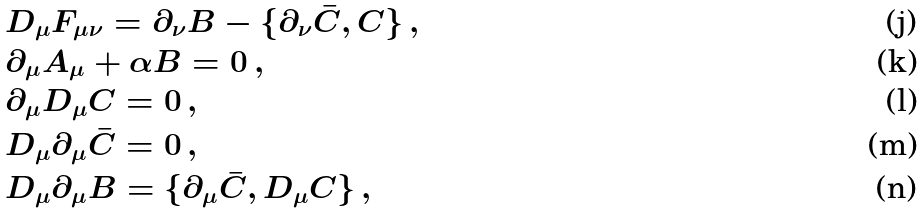<formula> <loc_0><loc_0><loc_500><loc_500>& D _ { \mu } F _ { \mu \nu } = \partial _ { \nu } B - \{ \partial _ { \nu } \bar { C } , C \} \, , \\ & \partial _ { \mu } A _ { \mu } + \alpha B = 0 \, , \\ & \partial _ { \mu } D _ { \mu } C = 0 \, , \\ & D _ { \mu } \partial _ { \mu } \bar { C } = 0 \, , \\ & D _ { \mu } \partial _ { \mu } B = \{ \partial _ { \mu } \bar { C } , D _ { \mu } C \} \, ,</formula> 